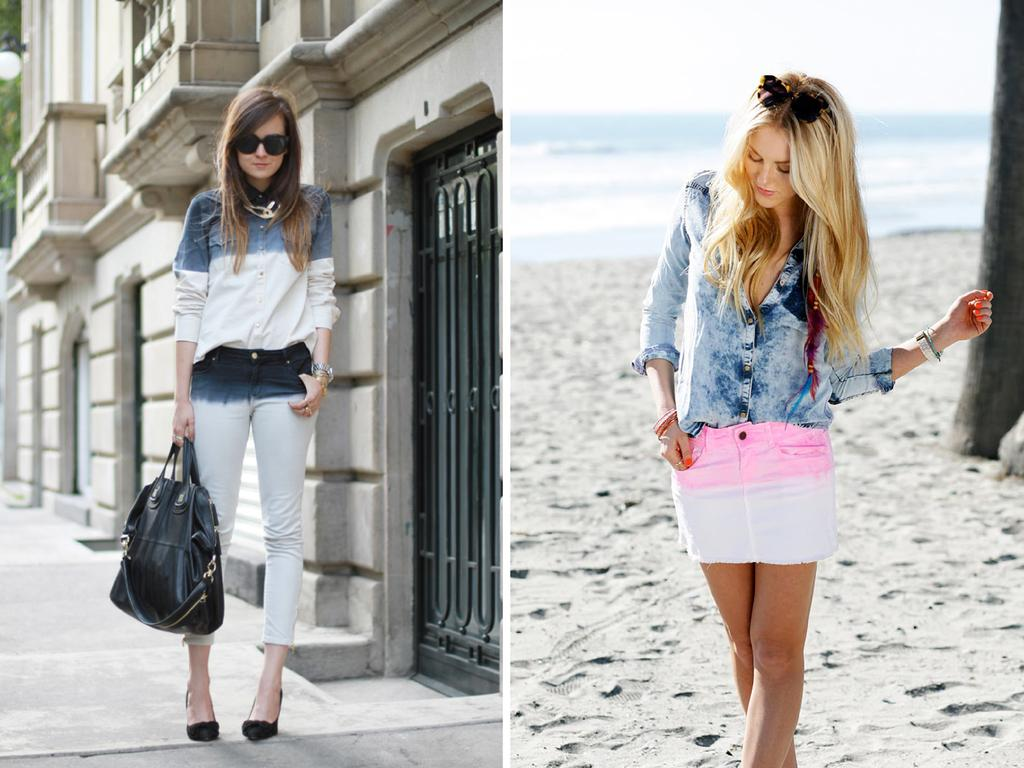What type of artwork is the image? The image is a collage. How many women are present in the image? There are two women in the image. What are the women doing in the image? Both women are giving poses. What is the woman on the left holding? The woman on the left is holding a handbag. What accessory is the woman on the left wearing? The woman on the left is wearing goggles. How many frogs can be seen in the image? There are no frogs present in the image. What type of fruit is the woman on the right holding in the image? There is no fruit visible in the image, and the woman on the right is not holding anything. 